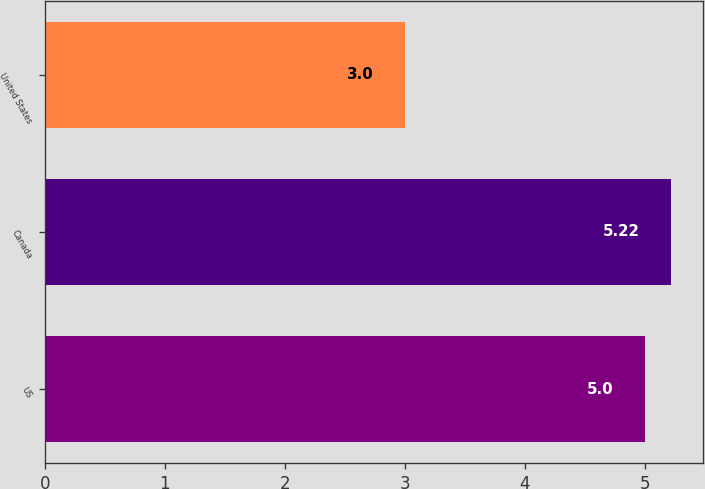Convert chart. <chart><loc_0><loc_0><loc_500><loc_500><bar_chart><fcel>US<fcel>Canada<fcel>United States<nl><fcel>5<fcel>5.22<fcel>3<nl></chart> 